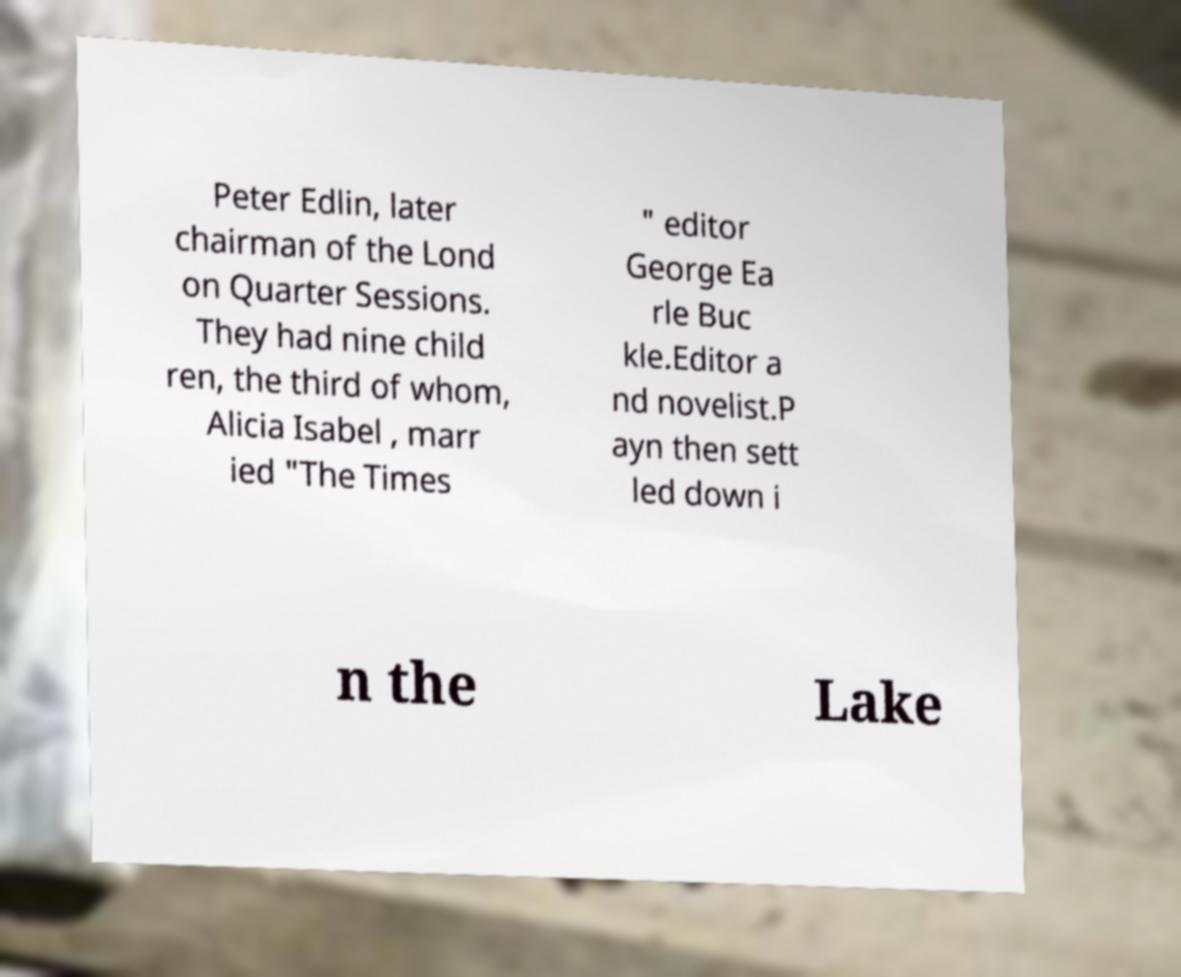Can you accurately transcribe the text from the provided image for me? Peter Edlin, later chairman of the Lond on Quarter Sessions. They had nine child ren, the third of whom, Alicia Isabel , marr ied "The Times " editor George Ea rle Buc kle.Editor a nd novelist.P ayn then sett led down i n the Lake 